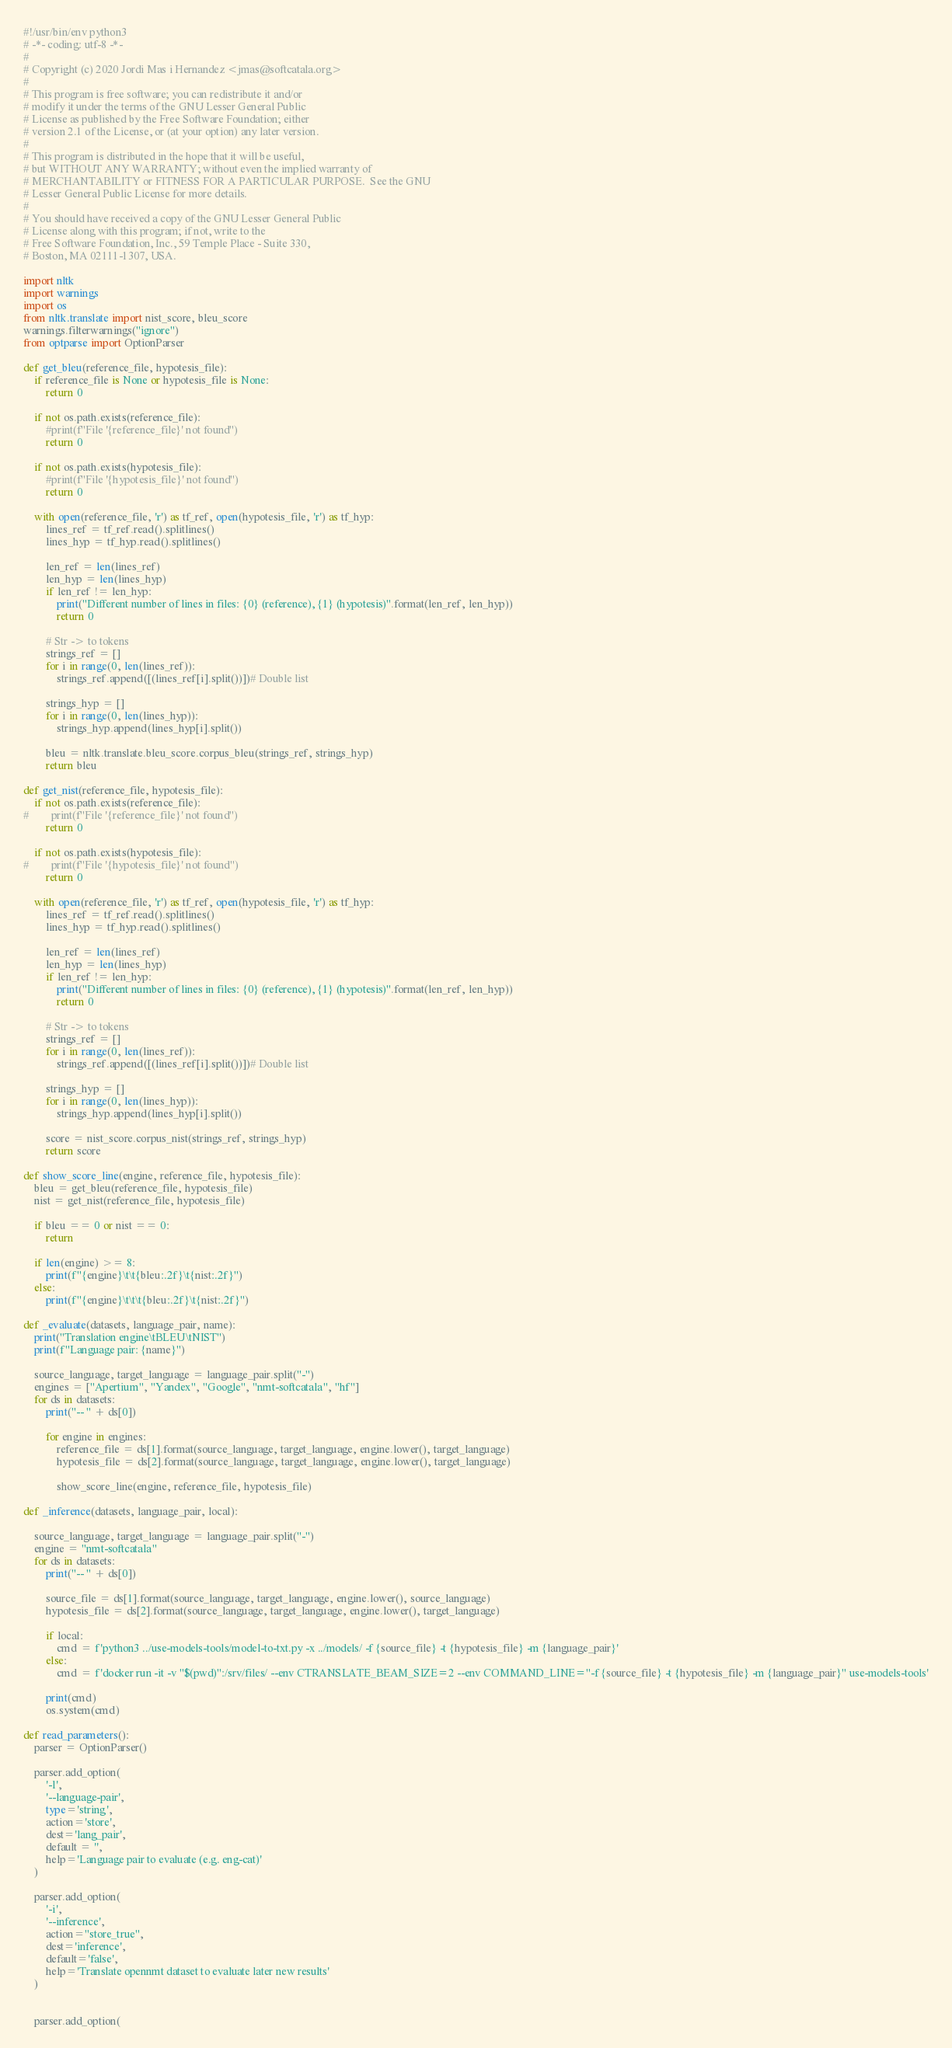<code> <loc_0><loc_0><loc_500><loc_500><_Python_>#!/usr/bin/env python3
# -*- coding: utf-8 -*-
#
# Copyright (c) 2020 Jordi Mas i Hernandez <jmas@softcatala.org>
#
# This program is free software; you can redistribute it and/or
# modify it under the terms of the GNU Lesser General Public
# License as published by the Free Software Foundation; either
# version 2.1 of the License, or (at your option) any later version.
#
# This program is distributed in the hope that it will be useful,
# but WITHOUT ANY WARRANTY; without even the implied warranty of
# MERCHANTABILITY or FITNESS FOR A PARTICULAR PURPOSE.  See the GNU
# Lesser General Public License for more details.
#
# You should have received a copy of the GNU Lesser General Public
# License along with this program; if not, write to the
# Free Software Foundation, Inc., 59 Temple Place - Suite 330,
# Boston, MA 02111-1307, USA.

import nltk
import warnings
import os
from nltk.translate import nist_score, bleu_score
warnings.filterwarnings("ignore")
from optparse import OptionParser

def get_bleu(reference_file, hypotesis_file):
    if reference_file is None or hypotesis_file is None:
        return 0

    if not os.path.exists(reference_file):
        #print(f"File '{reference_file}' not found")
        return 0

    if not os.path.exists(hypotesis_file):
        #print(f"File '{hypotesis_file}' not found")
        return 0

    with open(reference_file, 'r') as tf_ref, open(hypotesis_file, 'r') as tf_hyp:
        lines_ref = tf_ref.read().splitlines()
        lines_hyp = tf_hyp.read().splitlines()

        len_ref = len(lines_ref)
        len_hyp = len(lines_hyp)
        if len_ref != len_hyp:
            print("Different number of lines in files: {0} (reference), {1} (hypotesis)".format(len_ref, len_hyp))
            return 0

        # Str -> to tokens
        strings_ref = []
        for i in range(0, len(lines_ref)):
            strings_ref.append([(lines_ref[i].split())])# Double list

        strings_hyp = []
        for i in range(0, len(lines_hyp)):
            strings_hyp.append(lines_hyp[i].split())

        bleu = nltk.translate.bleu_score.corpus_bleu(strings_ref, strings_hyp)
        return bleu

def get_nist(reference_file, hypotesis_file):
    if not os.path.exists(reference_file):
#        print(f"File '{reference_file}' not found")
        return 0

    if not os.path.exists(hypotesis_file):
#        print(f"File '{hypotesis_file}' not found")
        return 0

    with open(reference_file, 'r') as tf_ref, open(hypotesis_file, 'r') as tf_hyp:
        lines_ref = tf_ref.read().splitlines()
        lines_hyp = tf_hyp.read().splitlines()

        len_ref = len(lines_ref)
        len_hyp = len(lines_hyp)
        if len_ref != len_hyp:
            print("Different number of lines in files: {0} (reference), {1} (hypotesis)".format(len_ref, len_hyp))
            return 0

        # Str -> to tokens
        strings_ref = []
        for i in range(0, len(lines_ref)):
            strings_ref.append([(lines_ref[i].split())])# Double list

        strings_hyp = []
        for i in range(0, len(lines_hyp)):
            strings_hyp.append(lines_hyp[i].split())

        score = nist_score.corpus_nist(strings_ref, strings_hyp)
        return score

def show_score_line(engine, reference_file, hypotesis_file):
    bleu = get_bleu(reference_file, hypotesis_file)
    nist = get_nist(reference_file, hypotesis_file)

    if bleu == 0 or nist == 0:
        return

    if len(engine) >= 8:
        print(f"{engine}\t\t{bleu:.2f}\t{nist:.2f}")
    else:
        print(f"{engine}\t\t\t{bleu:.2f}\t{nist:.2f}")

def _evaluate(datasets, language_pair, name):
    print("Translation engine\tBLEU\tNIST")
    print(f"Language pair: {name}")

    source_language, target_language = language_pair.split("-")
    engines = ["Apertium", "Yandex", "Google", "nmt-softcatala", "hf"]
    for ds in datasets:
        print("-- " + ds[0])

        for engine in engines:
            reference_file = ds[1].format(source_language, target_language, engine.lower(), target_language)
            hypotesis_file = ds[2].format(source_language, target_language, engine.lower(), target_language)

            show_score_line(engine, reference_file, hypotesis_file)

def _inference(datasets, language_pair, local):

    source_language, target_language = language_pair.split("-")
    engine = "nmt-softcatala"
    for ds in datasets:
        print("-- " + ds[0])

        source_file = ds[1].format(source_language, target_language, engine.lower(), source_language)
        hypotesis_file = ds[2].format(source_language, target_language, engine.lower(), target_language)

        if local:
            cmd = f'python3 ../use-models-tools/model-to-txt.py -x ../models/ -f {source_file} -t {hypotesis_file} -m {language_pair}'
        else:
            cmd = f'docker run -it -v "$(pwd)":/srv/files/ --env CTRANSLATE_BEAM_SIZE=2 --env COMMAND_LINE="-f {source_file} -t {hypotesis_file} -m {language_pair}" use-models-tools'

        print(cmd)
        os.system(cmd)

def read_parameters():
    parser = OptionParser()

    parser.add_option(
        '-l',
        '--language-pair',
        type='string',
        action='store',
        dest='lang_pair',
        default = '',
        help='Language pair to evaluate (e.g. eng-cat)'
    )

    parser.add_option(
        '-i',
        '--inference',
        action="store_true",
        dest='inference',
        default='false',
        help='Translate opennmt dataset to evaluate later new results'
    )


    parser.add_option(</code> 